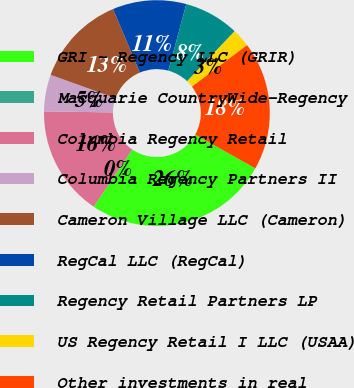<chart> <loc_0><loc_0><loc_500><loc_500><pie_chart><fcel>GRI - Regency LLC (GRIR)<fcel>Macquarie CountryWide-Regency<fcel>Columbia Regency Retail<fcel>Columbia Regency Partners II<fcel>Cameron Village LLC (Cameron)<fcel>RegCal LLC (RegCal)<fcel>Regency Retail Partners LP<fcel>US Regency Retail I LLC (USAA)<fcel>Other investments in real<nl><fcel>26.31%<fcel>0.0%<fcel>15.79%<fcel>5.26%<fcel>13.16%<fcel>10.53%<fcel>7.9%<fcel>2.63%<fcel>18.42%<nl></chart> 